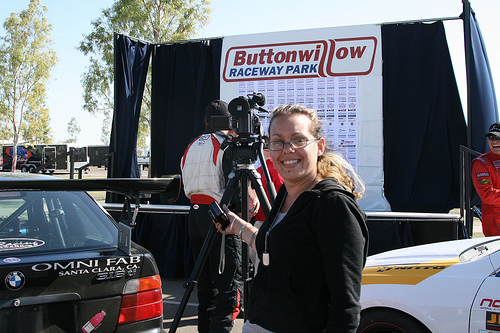<image>
Is there a lady to the left of the camera? No. The lady is not to the left of the camera. From this viewpoint, they have a different horizontal relationship. 